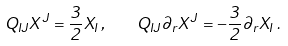Convert formula to latex. <formula><loc_0><loc_0><loc_500><loc_500>Q _ { I J } X ^ { J } = { \frac { 3 } { 2 } } X _ { I } \, , \quad Q _ { I J } \partial _ { r } X ^ { J } = - { \frac { 3 } { 2 } } \partial _ { r } X _ { I } \, .</formula> 